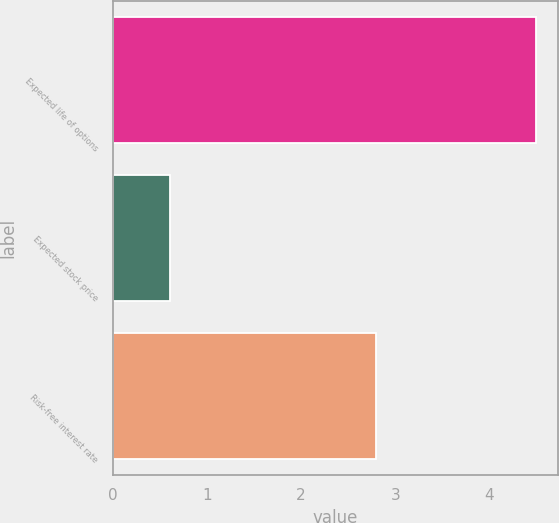Convert chart. <chart><loc_0><loc_0><loc_500><loc_500><bar_chart><fcel>Expected life of options<fcel>Expected stock price<fcel>Risk-free interest rate<nl><fcel>4.5<fcel>0.61<fcel>2.8<nl></chart> 